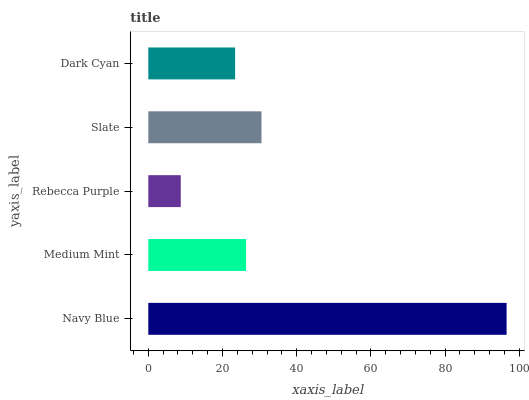Is Rebecca Purple the minimum?
Answer yes or no. Yes. Is Navy Blue the maximum?
Answer yes or no. Yes. Is Medium Mint the minimum?
Answer yes or no. No. Is Medium Mint the maximum?
Answer yes or no. No. Is Navy Blue greater than Medium Mint?
Answer yes or no. Yes. Is Medium Mint less than Navy Blue?
Answer yes or no. Yes. Is Medium Mint greater than Navy Blue?
Answer yes or no. No. Is Navy Blue less than Medium Mint?
Answer yes or no. No. Is Medium Mint the high median?
Answer yes or no. Yes. Is Medium Mint the low median?
Answer yes or no. Yes. Is Slate the high median?
Answer yes or no. No. Is Rebecca Purple the low median?
Answer yes or no. No. 